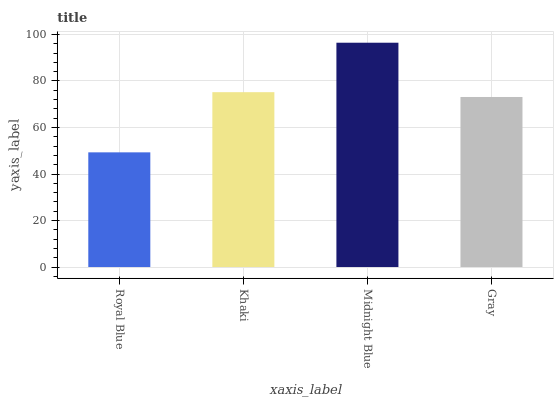Is Royal Blue the minimum?
Answer yes or no. Yes. Is Midnight Blue the maximum?
Answer yes or no. Yes. Is Khaki the minimum?
Answer yes or no. No. Is Khaki the maximum?
Answer yes or no. No. Is Khaki greater than Royal Blue?
Answer yes or no. Yes. Is Royal Blue less than Khaki?
Answer yes or no. Yes. Is Royal Blue greater than Khaki?
Answer yes or no. No. Is Khaki less than Royal Blue?
Answer yes or no. No. Is Khaki the high median?
Answer yes or no. Yes. Is Gray the low median?
Answer yes or no. Yes. Is Gray the high median?
Answer yes or no. No. Is Midnight Blue the low median?
Answer yes or no. No. 